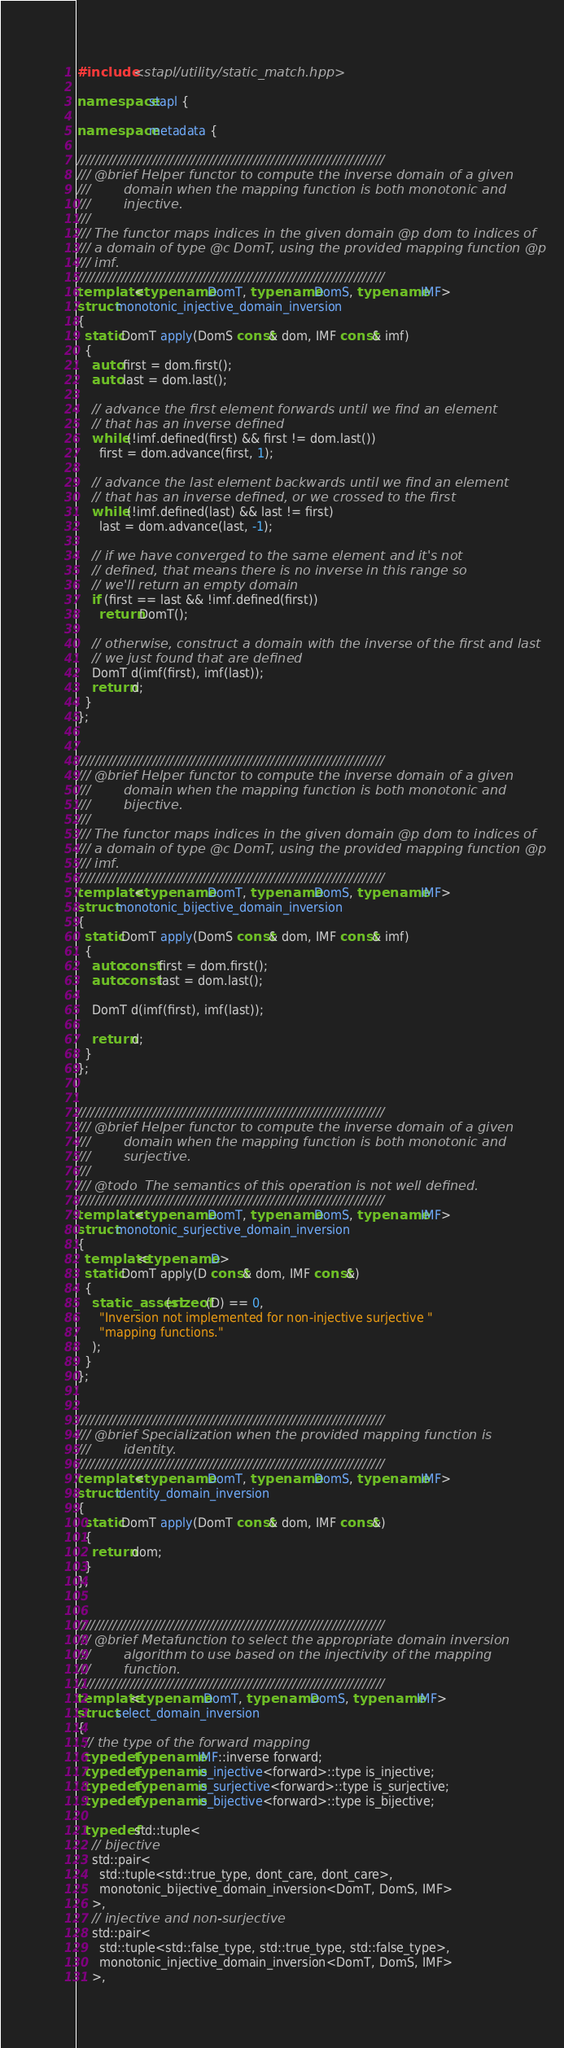Convert code to text. <code><loc_0><loc_0><loc_500><loc_500><_C++_>#include <stapl/utility/static_match.hpp>

namespace stapl {

namespace metadata {

//////////////////////////////////////////////////////////////////////
/// @brief Helper functor to compute the inverse domain of a given
///        domain when the mapping function is both monotonic and
///        injective.
///
/// The functor maps indices in the given domain @p dom to indices of
/// a domain of type @c DomT, using the provided mapping function @p
/// imf.
//////////////////////////////////////////////////////////////////////
template <typename DomT, typename DomS, typename IMF>
struct monotonic_injective_domain_inversion
{
  static DomT apply(DomS const& dom, IMF const& imf)
  {
    auto first = dom.first();
    auto last = dom.last();

    // advance the first element forwards until we find an element
    // that has an inverse defined
    while (!imf.defined(first) && first != dom.last())
      first = dom.advance(first, 1);

    // advance the last element backwards until we find an element
    // that has an inverse defined, or we crossed to the first
    while (!imf.defined(last) && last != first)
      last = dom.advance(last, -1);

    // if we have converged to the same element and it's not
    // defined, that means there is no inverse in this range so
    // we'll return an empty domain
    if (first == last && !imf.defined(first))
      return DomT();

    // otherwise, construct a domain with the inverse of the first and last
    // we just found that are defined
    DomT d(imf(first), imf(last));
    return d;
  }
};


//////////////////////////////////////////////////////////////////////
/// @brief Helper functor to compute the inverse domain of a given
///        domain when the mapping function is both monotonic and
///        bijective.
///
/// The functor maps indices in the given domain @p dom to indices of
/// a domain of type @c DomT, using the provided mapping function @p
/// imf.
//////////////////////////////////////////////////////////////////////
template <typename DomT, typename DomS, typename IMF>
struct monotonic_bijective_domain_inversion
{
  static DomT apply(DomS const& dom, IMF const& imf)
  {
    auto const first = dom.first();
    auto const last = dom.last();

    DomT d(imf(first), imf(last));

    return d;
  }
};


//////////////////////////////////////////////////////////////////////
/// @brief Helper functor to compute the inverse domain of a given
///        domain when the mapping function is both monotonic and
///        surjective.
///
/// @todo  The semantics of this operation is not well defined.
//////////////////////////////////////////////////////////////////////
template <typename DomT, typename DomS, typename IMF>
struct monotonic_surjective_domain_inversion
{
  template<typename D>
  static DomT apply(D const& dom, IMF const&)
  {
    static_assert(sizeof(D) == 0,
      "Inversion not implemented for non-injective surjective "
      "mapping functions."
    );
  }
};


//////////////////////////////////////////////////////////////////////
/// @brief Specialization when the provided mapping function is
///        identity.
//////////////////////////////////////////////////////////////////////
template <typename DomT, typename DomS, typename IMF>
struct identity_domain_inversion
{
  static DomT apply(DomT const& dom, IMF const&)
  {
    return dom;
  }
};


//////////////////////////////////////////////////////////////////////
/// @brief Metafunction to select the appropriate domain inversion
///        algorithm to use based on the injectivity of the mapping
///        function.
//////////////////////////////////////////////////////////////////////
template<typename DomT, typename DomS, typename IMF>
struct select_domain_inversion
{
  // the type of the forward mapping
  typedef typename IMF::inverse forward;
  typedef typename is_injective<forward>::type is_injective;
  typedef typename is_surjective<forward>::type is_surjective;
  typedef typename is_bijective<forward>::type is_bijective;

  typedef std::tuple<
    // bijective
    std::pair<
      std::tuple<std::true_type, dont_care, dont_care>,
      monotonic_bijective_domain_inversion<DomT, DomS, IMF>
    >,
    // injective and non-surjective
    std::pair<
      std::tuple<std::false_type, std::true_type, std::false_type>,
      monotonic_injective_domain_inversion<DomT, DomS, IMF>
    >,</code> 